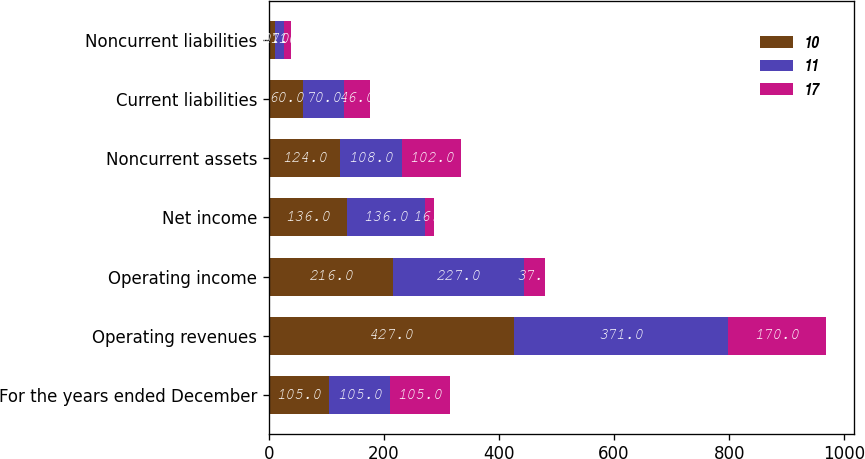Convert chart. <chart><loc_0><loc_0><loc_500><loc_500><stacked_bar_chart><ecel><fcel>For the years ended December<fcel>Operating revenues<fcel>Operating income<fcel>Net income<fcel>Noncurrent assets<fcel>Current liabilities<fcel>Noncurrent liabilities<nl><fcel>10<fcel>105<fcel>427<fcel>216<fcel>136<fcel>124<fcel>60<fcel>10<nl><fcel>11<fcel>105<fcel>371<fcel>227<fcel>136<fcel>108<fcel>70<fcel>17<nl><fcel>17<fcel>105<fcel>170<fcel>37<fcel>16<fcel>102<fcel>46<fcel>11<nl></chart> 